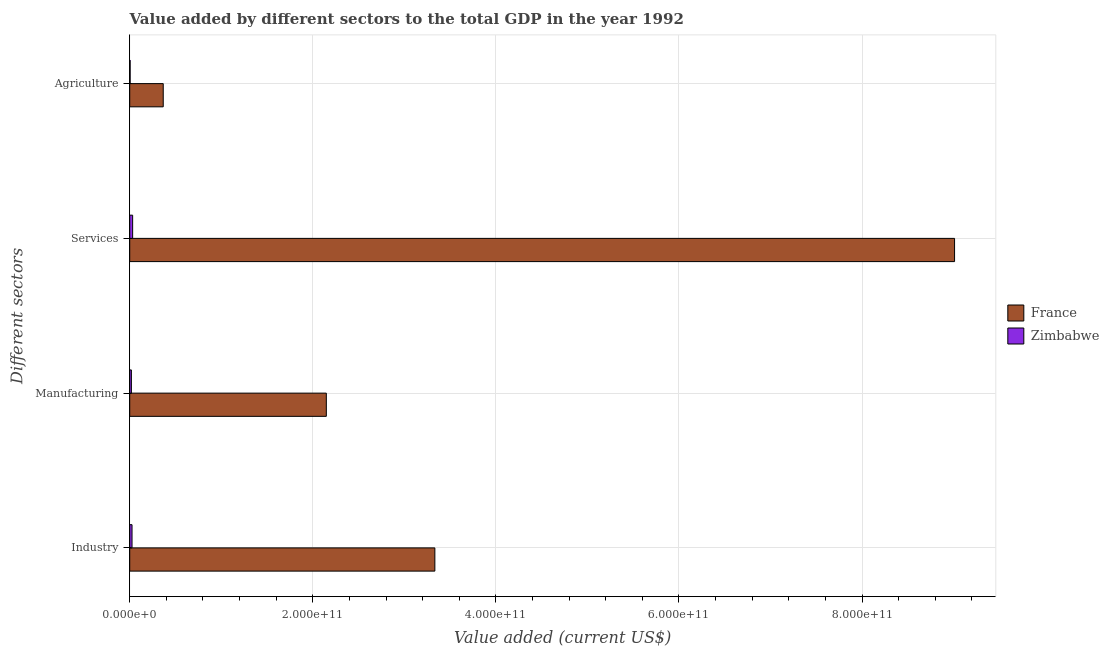How many different coloured bars are there?
Provide a short and direct response. 2. Are the number of bars per tick equal to the number of legend labels?
Your answer should be compact. Yes. How many bars are there on the 4th tick from the top?
Your response must be concise. 2. What is the label of the 3rd group of bars from the top?
Provide a short and direct response. Manufacturing. What is the value added by agricultural sector in Zimbabwe?
Provide a succinct answer. 4.56e+08. Across all countries, what is the maximum value added by services sector?
Make the answer very short. 9.01e+11. Across all countries, what is the minimum value added by agricultural sector?
Your answer should be compact. 4.56e+08. In which country was the value added by manufacturing sector maximum?
Keep it short and to the point. France. In which country was the value added by manufacturing sector minimum?
Ensure brevity in your answer.  Zimbabwe. What is the total value added by services sector in the graph?
Keep it short and to the point. 9.04e+11. What is the difference between the value added by agricultural sector in Zimbabwe and that in France?
Provide a short and direct response. -3.61e+1. What is the difference between the value added by manufacturing sector in France and the value added by services sector in Zimbabwe?
Your answer should be compact. 2.12e+11. What is the average value added by manufacturing sector per country?
Keep it short and to the point. 1.08e+11. What is the difference between the value added by agricultural sector and value added by industrial sector in Zimbabwe?
Make the answer very short. -2.06e+09. In how many countries, is the value added by industrial sector greater than 280000000000 US$?
Provide a short and direct response. 1. What is the ratio of the value added by industrial sector in Zimbabwe to that in France?
Your response must be concise. 0.01. What is the difference between the highest and the second highest value added by services sector?
Provide a short and direct response. 8.98e+11. What is the difference between the highest and the lowest value added by agricultural sector?
Make the answer very short. 3.61e+1. What does the 1st bar from the top in Industry represents?
Offer a terse response. Zimbabwe. Is it the case that in every country, the sum of the value added by industrial sector and value added by manufacturing sector is greater than the value added by services sector?
Your answer should be compact. No. How many bars are there?
Give a very brief answer. 8. How many countries are there in the graph?
Give a very brief answer. 2. What is the difference between two consecutive major ticks on the X-axis?
Your answer should be very brief. 2.00e+11. Are the values on the major ticks of X-axis written in scientific E-notation?
Make the answer very short. Yes. Does the graph contain any zero values?
Your response must be concise. No. How many legend labels are there?
Ensure brevity in your answer.  2. What is the title of the graph?
Your answer should be very brief. Value added by different sectors to the total GDP in the year 1992. Does "Euro area" appear as one of the legend labels in the graph?
Make the answer very short. No. What is the label or title of the X-axis?
Your answer should be very brief. Value added (current US$). What is the label or title of the Y-axis?
Provide a short and direct response. Different sectors. What is the Value added (current US$) of France in Industry?
Make the answer very short. 3.33e+11. What is the Value added (current US$) of Zimbabwe in Industry?
Provide a short and direct response. 2.51e+09. What is the Value added (current US$) of France in Manufacturing?
Keep it short and to the point. 2.15e+11. What is the Value added (current US$) in Zimbabwe in Manufacturing?
Provide a succinct answer. 1.82e+09. What is the Value added (current US$) of France in Services?
Provide a succinct answer. 9.01e+11. What is the Value added (current US$) in Zimbabwe in Services?
Ensure brevity in your answer.  3.18e+09. What is the Value added (current US$) in France in Agriculture?
Your answer should be very brief. 3.66e+1. What is the Value added (current US$) in Zimbabwe in Agriculture?
Make the answer very short. 4.56e+08. Across all Different sectors, what is the maximum Value added (current US$) in France?
Make the answer very short. 9.01e+11. Across all Different sectors, what is the maximum Value added (current US$) in Zimbabwe?
Your answer should be very brief. 3.18e+09. Across all Different sectors, what is the minimum Value added (current US$) of France?
Your answer should be very brief. 3.66e+1. Across all Different sectors, what is the minimum Value added (current US$) in Zimbabwe?
Your response must be concise. 4.56e+08. What is the total Value added (current US$) in France in the graph?
Give a very brief answer. 1.49e+12. What is the total Value added (current US$) in Zimbabwe in the graph?
Offer a terse response. 7.96e+09. What is the difference between the Value added (current US$) in France in Industry and that in Manufacturing?
Give a very brief answer. 1.19e+11. What is the difference between the Value added (current US$) in Zimbabwe in Industry and that in Manufacturing?
Give a very brief answer. 6.96e+08. What is the difference between the Value added (current US$) in France in Industry and that in Services?
Keep it short and to the point. -5.68e+11. What is the difference between the Value added (current US$) in Zimbabwe in Industry and that in Services?
Provide a short and direct response. -6.68e+08. What is the difference between the Value added (current US$) of France in Industry and that in Agriculture?
Your response must be concise. 2.97e+11. What is the difference between the Value added (current US$) of Zimbabwe in Industry and that in Agriculture?
Make the answer very short. 2.06e+09. What is the difference between the Value added (current US$) of France in Manufacturing and that in Services?
Provide a short and direct response. -6.86e+11. What is the difference between the Value added (current US$) of Zimbabwe in Manufacturing and that in Services?
Provide a short and direct response. -1.36e+09. What is the difference between the Value added (current US$) in France in Manufacturing and that in Agriculture?
Your answer should be compact. 1.78e+11. What is the difference between the Value added (current US$) in Zimbabwe in Manufacturing and that in Agriculture?
Provide a short and direct response. 1.36e+09. What is the difference between the Value added (current US$) of France in Services and that in Agriculture?
Provide a short and direct response. 8.65e+11. What is the difference between the Value added (current US$) in Zimbabwe in Services and that in Agriculture?
Your response must be concise. 2.72e+09. What is the difference between the Value added (current US$) in France in Industry and the Value added (current US$) in Zimbabwe in Manufacturing?
Make the answer very short. 3.32e+11. What is the difference between the Value added (current US$) of France in Industry and the Value added (current US$) of Zimbabwe in Services?
Ensure brevity in your answer.  3.30e+11. What is the difference between the Value added (current US$) of France in Industry and the Value added (current US$) of Zimbabwe in Agriculture?
Make the answer very short. 3.33e+11. What is the difference between the Value added (current US$) in France in Manufacturing and the Value added (current US$) in Zimbabwe in Services?
Give a very brief answer. 2.12e+11. What is the difference between the Value added (current US$) in France in Manufacturing and the Value added (current US$) in Zimbabwe in Agriculture?
Your response must be concise. 2.14e+11. What is the difference between the Value added (current US$) of France in Services and the Value added (current US$) of Zimbabwe in Agriculture?
Keep it short and to the point. 9.01e+11. What is the average Value added (current US$) of France per Different sectors?
Offer a terse response. 3.71e+11. What is the average Value added (current US$) of Zimbabwe per Different sectors?
Your response must be concise. 1.99e+09. What is the difference between the Value added (current US$) in France and Value added (current US$) in Zimbabwe in Industry?
Provide a short and direct response. 3.31e+11. What is the difference between the Value added (current US$) of France and Value added (current US$) of Zimbabwe in Manufacturing?
Provide a succinct answer. 2.13e+11. What is the difference between the Value added (current US$) of France and Value added (current US$) of Zimbabwe in Services?
Keep it short and to the point. 8.98e+11. What is the difference between the Value added (current US$) in France and Value added (current US$) in Zimbabwe in Agriculture?
Provide a short and direct response. 3.61e+1. What is the ratio of the Value added (current US$) of France in Industry to that in Manufacturing?
Keep it short and to the point. 1.55. What is the ratio of the Value added (current US$) in Zimbabwe in Industry to that in Manufacturing?
Offer a very short reply. 1.38. What is the ratio of the Value added (current US$) of France in Industry to that in Services?
Give a very brief answer. 0.37. What is the ratio of the Value added (current US$) of Zimbabwe in Industry to that in Services?
Your response must be concise. 0.79. What is the ratio of the Value added (current US$) of France in Industry to that in Agriculture?
Give a very brief answer. 9.11. What is the ratio of the Value added (current US$) in Zimbabwe in Industry to that in Agriculture?
Make the answer very short. 5.51. What is the ratio of the Value added (current US$) of France in Manufacturing to that in Services?
Offer a very short reply. 0.24. What is the ratio of the Value added (current US$) in Zimbabwe in Manufacturing to that in Services?
Your answer should be very brief. 0.57. What is the ratio of the Value added (current US$) in France in Manufacturing to that in Agriculture?
Your response must be concise. 5.87. What is the ratio of the Value added (current US$) in Zimbabwe in Manufacturing to that in Agriculture?
Provide a succinct answer. 3.98. What is the ratio of the Value added (current US$) of France in Services to that in Agriculture?
Offer a very short reply. 24.62. What is the ratio of the Value added (current US$) in Zimbabwe in Services to that in Agriculture?
Make the answer very short. 6.98. What is the difference between the highest and the second highest Value added (current US$) in France?
Your response must be concise. 5.68e+11. What is the difference between the highest and the second highest Value added (current US$) in Zimbabwe?
Ensure brevity in your answer.  6.68e+08. What is the difference between the highest and the lowest Value added (current US$) of France?
Offer a terse response. 8.65e+11. What is the difference between the highest and the lowest Value added (current US$) of Zimbabwe?
Offer a very short reply. 2.72e+09. 